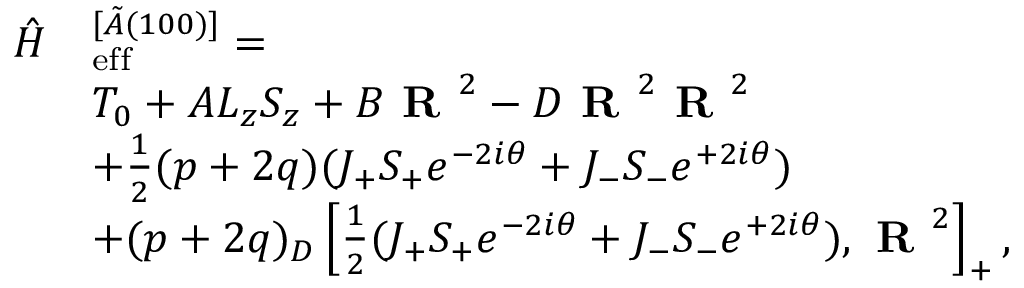Convert formula to latex. <formula><loc_0><loc_0><loc_500><loc_500>\begin{array} { r l } { \hat { H } } & { _ { e } f f ^ { [ \tilde { A } ( 1 0 0 ) ] } = } \\ & { T _ { 0 } + A L _ { z } S _ { z } + B R ^ { 2 } - D R ^ { 2 } R ^ { 2 } } \\ & { + \frac { 1 } { 2 } ( p + 2 q ) ( J _ { + } S _ { + } e ^ { - 2 i \theta } + J _ { - } S _ { - } e ^ { + 2 i \theta } ) } \\ & { + ( p + 2 q ) _ { D } \left [ \frac { 1 } { 2 } ( J _ { + } S _ { + } e ^ { - 2 i \theta } + J _ { - } S _ { - } e ^ { + 2 i \theta } ) , R ^ { 2 } \right ] _ { + } , } \end{array}</formula> 